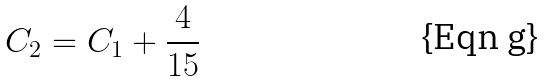Convert formula to latex. <formula><loc_0><loc_0><loc_500><loc_500>C _ { 2 } = C _ { 1 } + \frac { 4 } { 1 5 }</formula> 